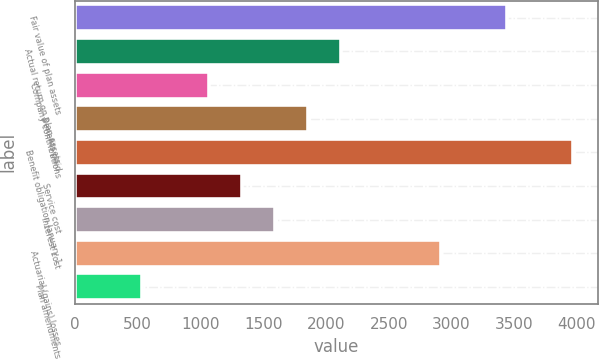<chart> <loc_0><loc_0><loc_500><loc_500><bar_chart><fcel>Fair value of plan assets<fcel>Actual return on plan assets<fcel>Company contributions<fcel>Benefits paid<fcel>Benefit obligation January 1<fcel>Service cost<fcel>Interest cost<fcel>Actuarial (gains) losses<fcel>Plan amendments<nl><fcel>3442.6<fcel>2121.6<fcel>1064.8<fcel>1857.4<fcel>3971<fcel>1329<fcel>1593.2<fcel>2914.2<fcel>536.4<nl></chart> 